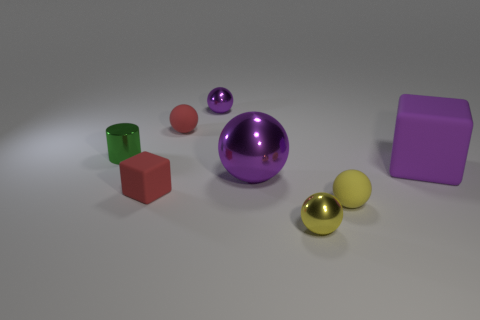Which objects in the image are closest to each other? The two spherical objects, one gold and one silver, are closest to each other. They appear to be almost touching. 